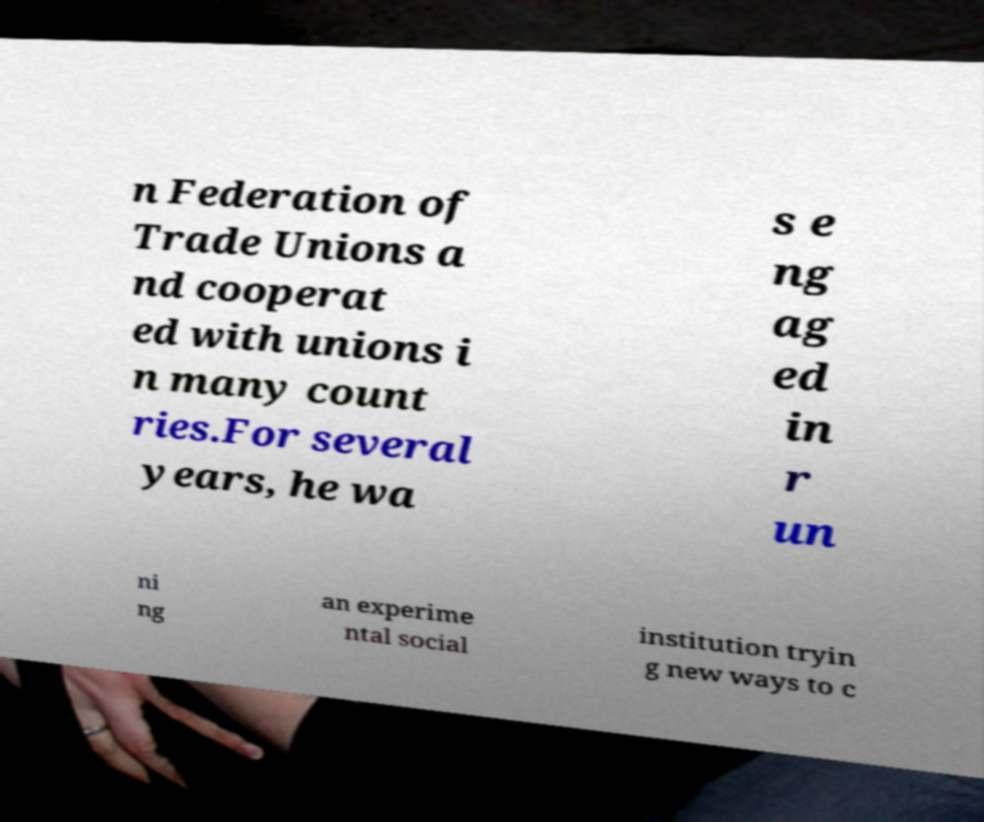I need the written content from this picture converted into text. Can you do that? n Federation of Trade Unions a nd cooperat ed with unions i n many count ries.For several years, he wa s e ng ag ed in r un ni ng an experime ntal social institution tryin g new ways to c 